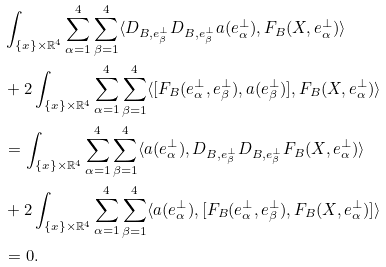<formula> <loc_0><loc_0><loc_500><loc_500>& \int _ { \{ x \} \times \mathbb { R } ^ { 4 } } \sum _ { \alpha = 1 } ^ { 4 } \sum _ { \beta = 1 } ^ { 4 } \langle D _ { B , e _ { \beta } ^ { \perp } } D _ { B , e _ { \beta } ^ { \perp } } a ( e _ { \alpha } ^ { \perp } ) , F _ { B } ( X , e _ { \alpha } ^ { \perp } ) \rangle \\ & + 2 \int _ { \{ x \} \times \mathbb { R } ^ { 4 } } \sum _ { \alpha = 1 } ^ { 4 } \sum _ { \beta = 1 } ^ { 4 } \langle [ F _ { B } ( e _ { \alpha } ^ { \perp } , e _ { \beta } ^ { \perp } ) , a ( e _ { \beta } ^ { \perp } ) ] , F _ { B } ( X , e _ { \alpha } ^ { \perp } ) \rangle \\ & = \int _ { \{ x \} \times \mathbb { R } ^ { 4 } } \sum _ { \alpha = 1 } ^ { 4 } \sum _ { \beta = 1 } ^ { 4 } \langle a ( e _ { \alpha } ^ { \perp } ) , D _ { B , e _ { \beta } ^ { \perp } } D _ { B , e _ { \beta } ^ { \perp } } F _ { B } ( X , e _ { \alpha } ^ { \perp } ) \rangle \\ & + 2 \int _ { \{ x \} \times \mathbb { R } ^ { 4 } } \sum _ { \alpha = 1 } ^ { 4 } \sum _ { \beta = 1 } ^ { 4 } \langle a ( e _ { \alpha } ^ { \perp } ) , [ F _ { B } ( e _ { \alpha } ^ { \perp } , e _ { \beta } ^ { \perp } ) , F _ { B } ( X , e _ { \alpha } ^ { \perp } ) ] \rangle \\ & = 0 .</formula> 